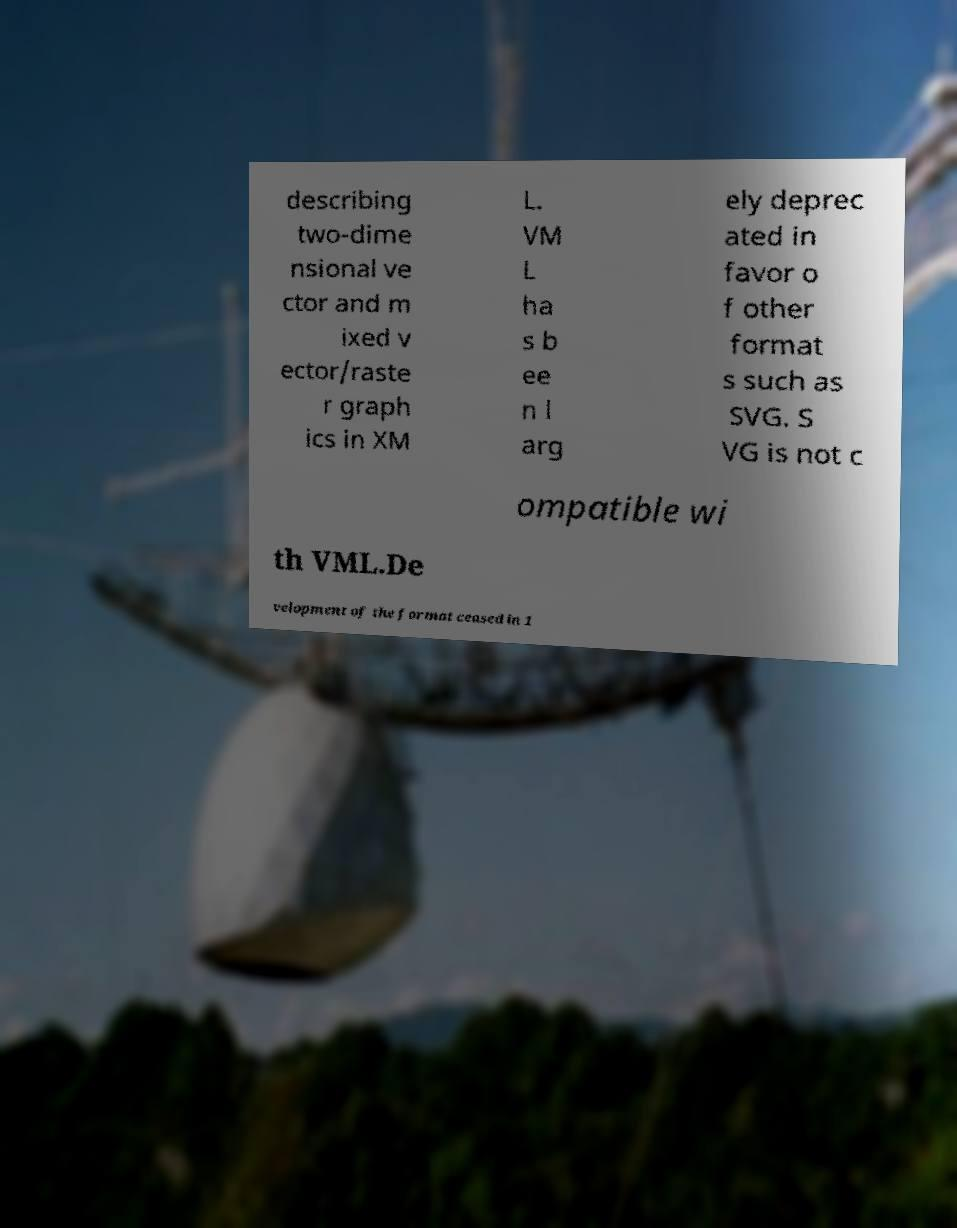Can you read and provide the text displayed in the image?This photo seems to have some interesting text. Can you extract and type it out for me? describing two-dime nsional ve ctor and m ixed v ector/raste r graph ics in XM L. VM L ha s b ee n l arg ely deprec ated in favor o f other format s such as SVG. S VG is not c ompatible wi th VML.De velopment of the format ceased in 1 